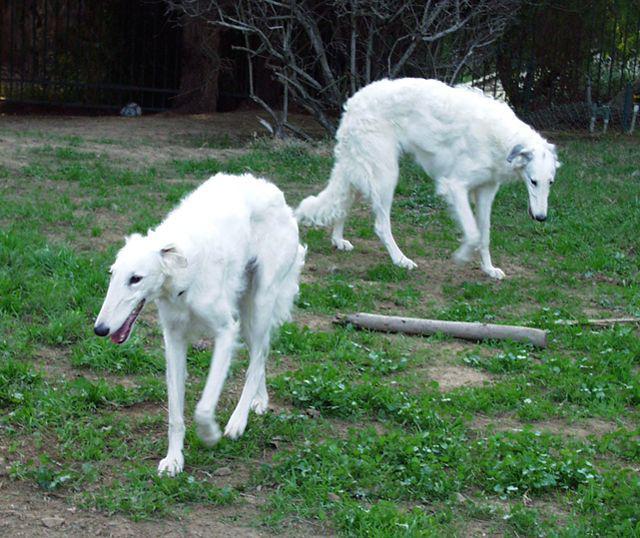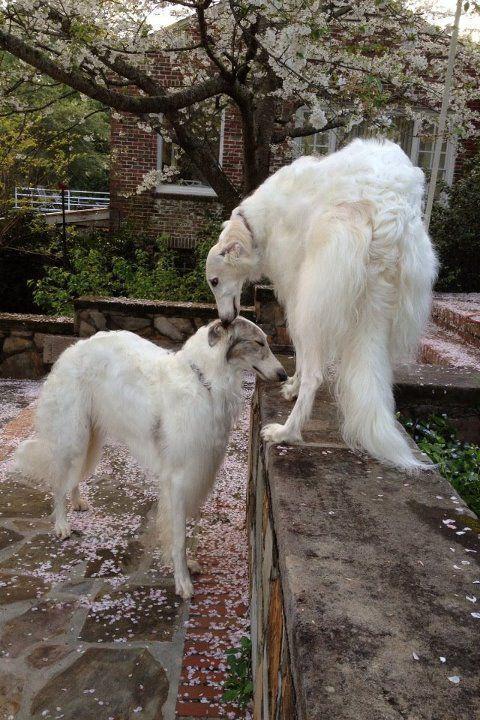The first image is the image on the left, the second image is the image on the right. Considering the images on both sides, is "An image shows a human hand next to the head of a hound posed in front of ornate architecture." valid? Answer yes or no. No. The first image is the image on the left, the second image is the image on the right. Examine the images to the left and right. Is the description "One image shows at least one large dog with a handler at a majestic building, while the other image of at least two dogs is set in a rustic outdoor area." accurate? Answer yes or no. No. 